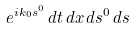<formula> <loc_0><loc_0><loc_500><loc_500>e ^ { i k _ { 0 } s ^ { 0 } } \, d t \, d x \, d s ^ { 0 } \, d s</formula> 